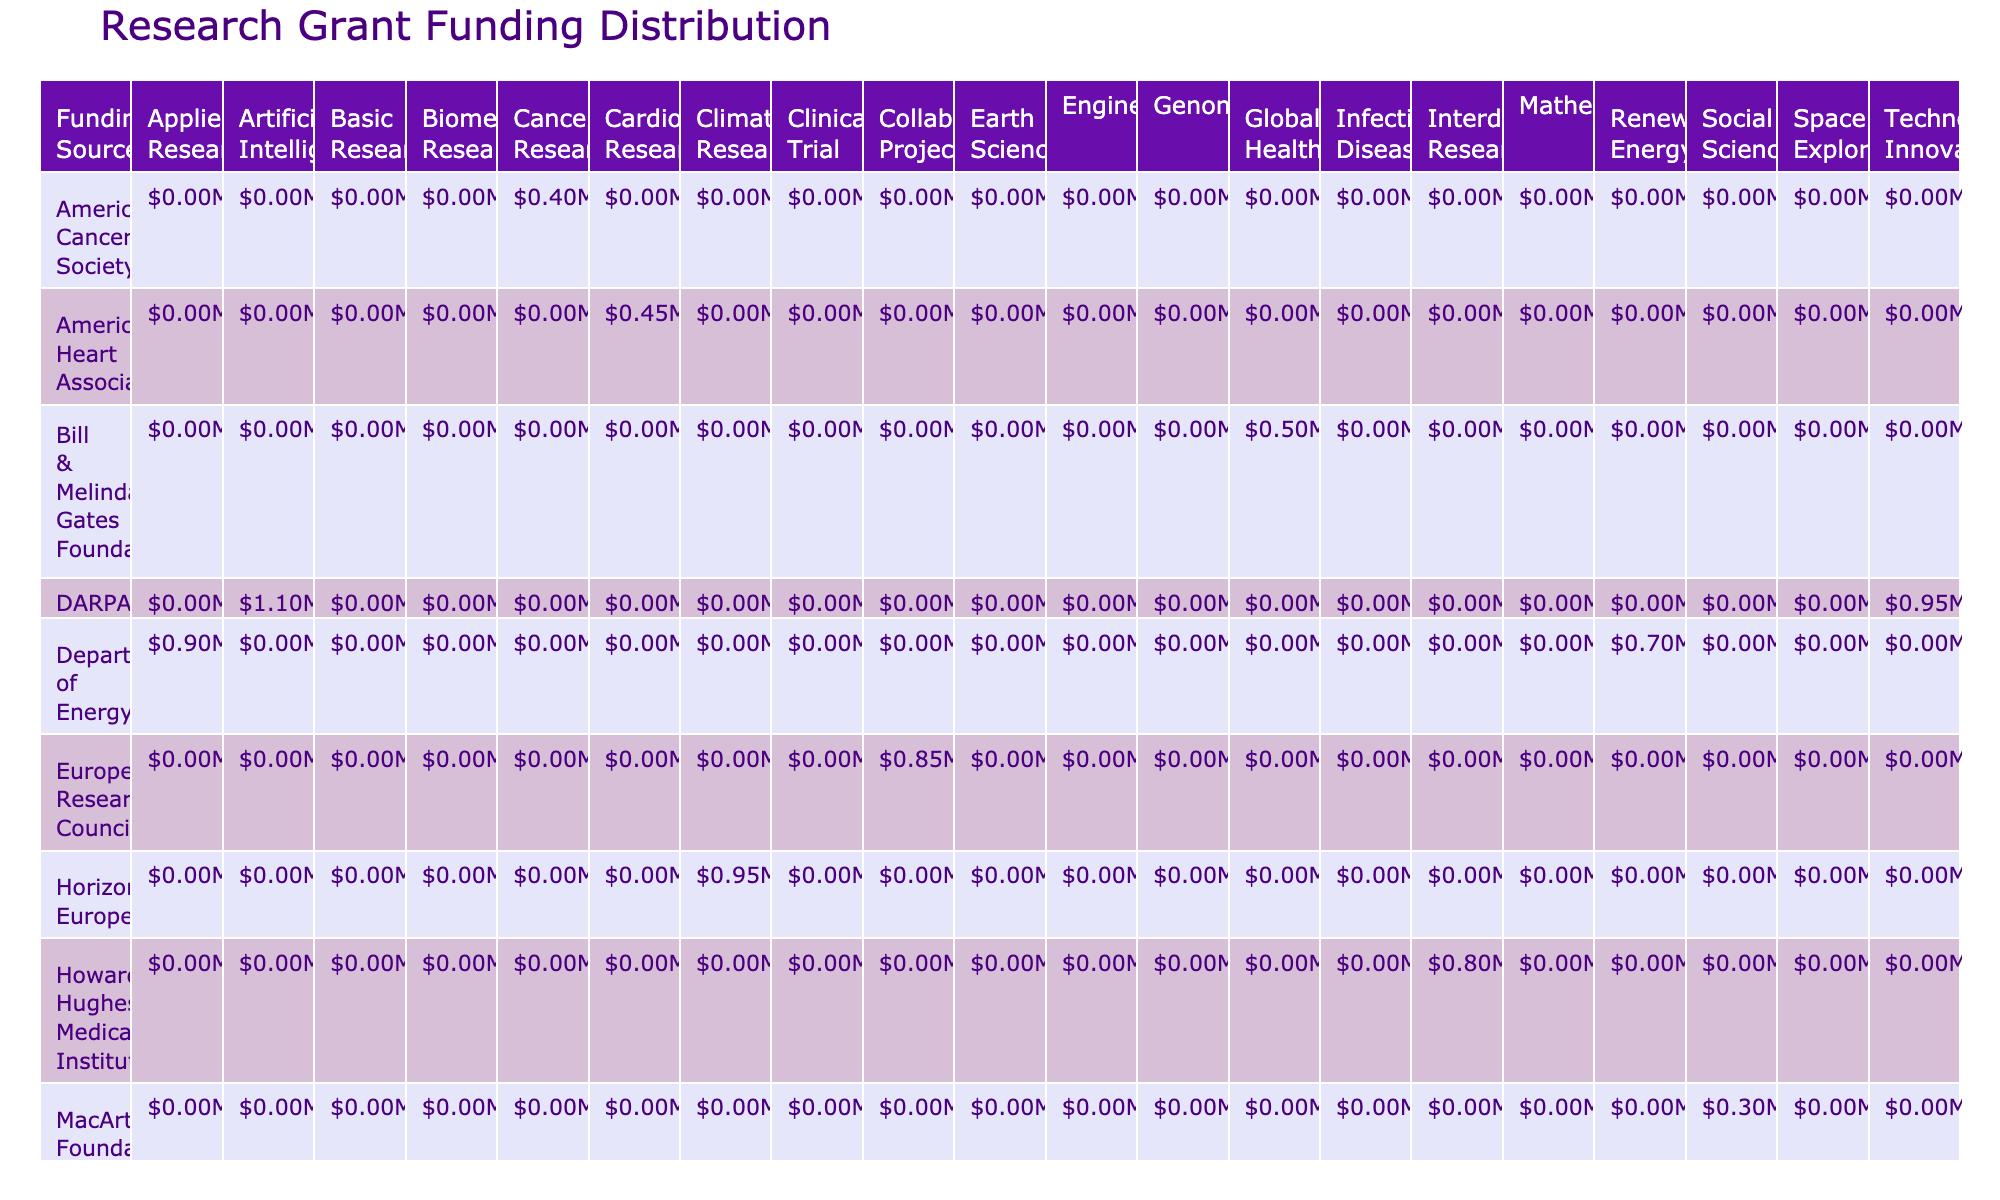What is the total funding amount provided by the National Institutes of Health for research projects in 2023? The National Institutes of Health provided funding for two project types in 2023: Clinical Trial (1,200,000) and Genomics (1,000,000). Summing these amounts gives us 1,200,000 + 1,000,000 = 2,200,000.
Answer: 2,200,000 Which funding source provided the highest amount for Space Exploration? The only entry for Space Exploration is from NASA, which provided 1,100,000 in 2023. Since there are no other funding sources listed for this project type, NASA provided the highest amount.
Answer: NASA, 1,100,000 How much funding was allocated to Clinical Trials and Biomedical Research in total? The amount allocated to Clinical Trials from the National Institutes of Health is 1,200,000, and for Biomedical Research from Wellcome Trust, it is 600,000. Adding these gives us 1,200,000 + 600,000 = 1,800,000.
Answer: 1,800,000 Is there a funding source that provided at least 1 million for any Global Health project? The only funding source for Global Health projects listed is the Bill & Melinda Gates Foundation, which provided 500,000. Since 500,000 is less than 1 million, the answer is no.
Answer: No Which project type received the most overall funding from all sources combined? For Basic Research, the total is 750,000; for Clinical Trial, it's 1,200,000; for Applied Research, 900,000; for Global Health, 500,000; for Collaborative Project, 850,000; for Space Exploration, 1,100,000; for Biomedical Research, 600,000; for Cancer Research, 400,000; for Interdisciplinary Research, 800,000; for Engineering, 550,000; for Genomics, 1,000,000; for Renewable Energy, 700,000; for Social Sciences, 300,000; for Climate Research, 950,000; for Earth Science, 650,000; for Infectious Diseases, 750,000; for Artificial Intelligence, 1,100,000; and for Cardiovascular Research, 450,000. Summing these amounts reveals the largest is Clinical Trial at 1,200,000.
Answer: Clinical Trial, 1,200,000 